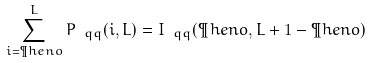<formula> <loc_0><loc_0><loc_500><loc_500>\sum _ { i = \P h e n o } ^ { L } P _ { \ q q } ( i , L ) = I _ { \ q q } ( \P h e n o , L + 1 - \P h e n o )</formula> 